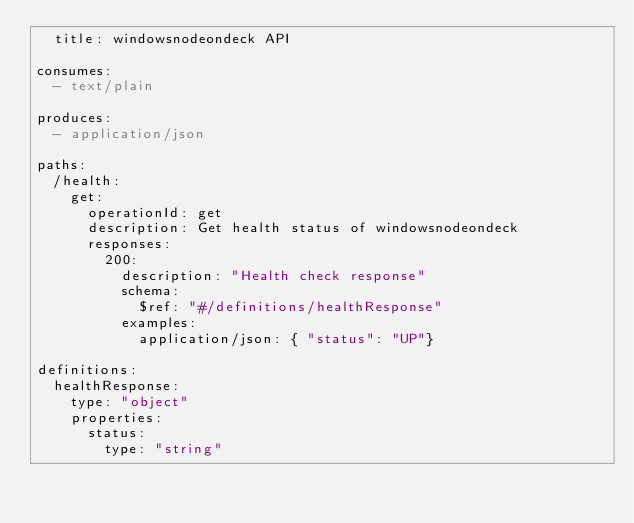<code> <loc_0><loc_0><loc_500><loc_500><_YAML_>  title: windowsnodeondeck API

consumes:
  - text/plain

produces:
  - application/json

paths:
  /health:
    get:
      operationId: get
      description: Get health status of windowsnodeondeck
      responses:
        200:
          description: "Health check response"
          schema:
            $ref: "#/definitions/healthResponse"
          examples:
            application/json: { "status": "UP"}

definitions:
  healthResponse:
    type: "object"
    properties:
      status:
        type: "string"</code> 